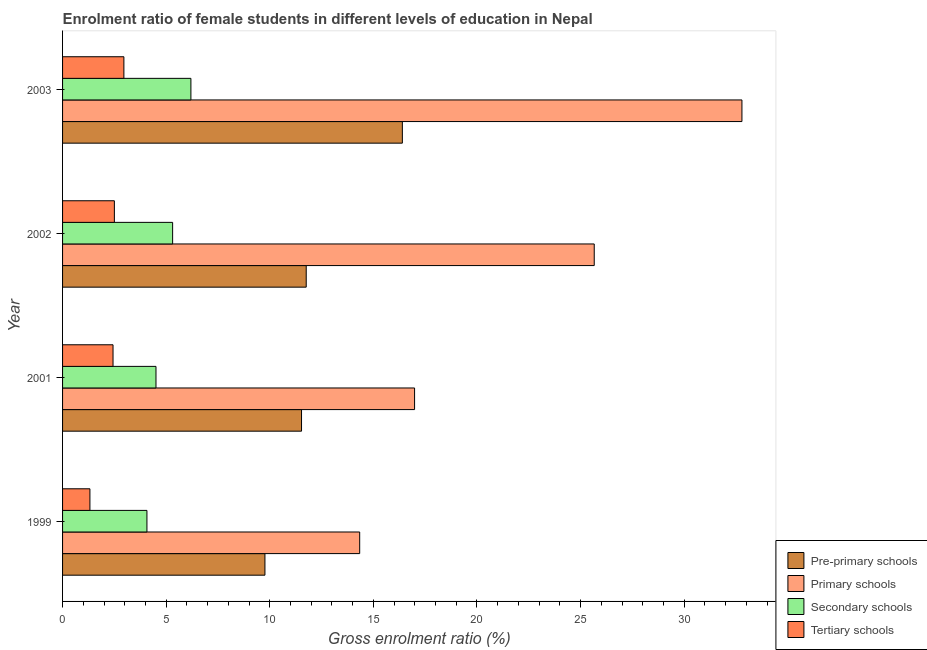How many groups of bars are there?
Provide a succinct answer. 4. Are the number of bars per tick equal to the number of legend labels?
Give a very brief answer. Yes. How many bars are there on the 2nd tick from the bottom?
Give a very brief answer. 4. What is the gross enrolment ratio(male) in primary schools in 2002?
Your response must be concise. 25.66. Across all years, what is the maximum gross enrolment ratio(male) in primary schools?
Offer a terse response. 32.79. Across all years, what is the minimum gross enrolment ratio(male) in primary schools?
Your answer should be very brief. 14.34. In which year was the gross enrolment ratio(male) in primary schools minimum?
Your answer should be compact. 1999. What is the total gross enrolment ratio(male) in primary schools in the graph?
Provide a short and direct response. 89.78. What is the difference between the gross enrolment ratio(male) in secondary schools in 1999 and that in 2001?
Keep it short and to the point. -0.44. What is the difference between the gross enrolment ratio(male) in secondary schools in 2002 and the gross enrolment ratio(male) in primary schools in 2003?
Your response must be concise. -27.48. What is the average gross enrolment ratio(male) in pre-primary schools per year?
Give a very brief answer. 12.37. In the year 2001, what is the difference between the gross enrolment ratio(male) in secondary schools and gross enrolment ratio(male) in primary schools?
Your answer should be compact. -12.48. In how many years, is the gross enrolment ratio(male) in pre-primary schools greater than 23 %?
Give a very brief answer. 0. What is the ratio of the gross enrolment ratio(male) in secondary schools in 1999 to that in 2002?
Keep it short and to the point. 0.77. Is the gross enrolment ratio(male) in tertiary schools in 2001 less than that in 2003?
Ensure brevity in your answer.  Yes. Is the difference between the gross enrolment ratio(male) in secondary schools in 2002 and 2003 greater than the difference between the gross enrolment ratio(male) in pre-primary schools in 2002 and 2003?
Your answer should be compact. Yes. What is the difference between the highest and the second highest gross enrolment ratio(male) in primary schools?
Provide a short and direct response. 7.13. What is the difference between the highest and the lowest gross enrolment ratio(male) in primary schools?
Provide a short and direct response. 18.45. In how many years, is the gross enrolment ratio(male) in primary schools greater than the average gross enrolment ratio(male) in primary schools taken over all years?
Your answer should be compact. 2. Is the sum of the gross enrolment ratio(male) in primary schools in 1999 and 2003 greater than the maximum gross enrolment ratio(male) in pre-primary schools across all years?
Keep it short and to the point. Yes. What does the 4th bar from the top in 2001 represents?
Make the answer very short. Pre-primary schools. What does the 1st bar from the bottom in 2003 represents?
Keep it short and to the point. Pre-primary schools. What is the difference between two consecutive major ticks on the X-axis?
Keep it short and to the point. 5. Does the graph contain any zero values?
Make the answer very short. No. Does the graph contain grids?
Your answer should be compact. No. Where does the legend appear in the graph?
Provide a short and direct response. Bottom right. How many legend labels are there?
Make the answer very short. 4. What is the title of the graph?
Give a very brief answer. Enrolment ratio of female students in different levels of education in Nepal. Does "UNRWA" appear as one of the legend labels in the graph?
Your answer should be very brief. No. What is the label or title of the X-axis?
Your answer should be very brief. Gross enrolment ratio (%). What is the Gross enrolment ratio (%) in Pre-primary schools in 1999?
Provide a succinct answer. 9.77. What is the Gross enrolment ratio (%) in Primary schools in 1999?
Make the answer very short. 14.34. What is the Gross enrolment ratio (%) in Secondary schools in 1999?
Give a very brief answer. 4.07. What is the Gross enrolment ratio (%) in Tertiary schools in 1999?
Provide a short and direct response. 1.32. What is the Gross enrolment ratio (%) in Pre-primary schools in 2001?
Make the answer very short. 11.53. What is the Gross enrolment ratio (%) in Primary schools in 2001?
Ensure brevity in your answer.  16.99. What is the Gross enrolment ratio (%) of Secondary schools in 2001?
Your answer should be compact. 4.51. What is the Gross enrolment ratio (%) of Tertiary schools in 2001?
Make the answer very short. 2.44. What is the Gross enrolment ratio (%) in Pre-primary schools in 2002?
Your answer should be very brief. 11.76. What is the Gross enrolment ratio (%) of Primary schools in 2002?
Provide a short and direct response. 25.66. What is the Gross enrolment ratio (%) of Secondary schools in 2002?
Provide a short and direct response. 5.31. What is the Gross enrolment ratio (%) in Tertiary schools in 2002?
Make the answer very short. 2.5. What is the Gross enrolment ratio (%) in Pre-primary schools in 2003?
Provide a short and direct response. 16.4. What is the Gross enrolment ratio (%) in Primary schools in 2003?
Your response must be concise. 32.79. What is the Gross enrolment ratio (%) in Secondary schools in 2003?
Your answer should be very brief. 6.19. What is the Gross enrolment ratio (%) of Tertiary schools in 2003?
Offer a very short reply. 2.96. Across all years, what is the maximum Gross enrolment ratio (%) in Pre-primary schools?
Your answer should be very brief. 16.4. Across all years, what is the maximum Gross enrolment ratio (%) in Primary schools?
Your response must be concise. 32.79. Across all years, what is the maximum Gross enrolment ratio (%) in Secondary schools?
Ensure brevity in your answer.  6.19. Across all years, what is the maximum Gross enrolment ratio (%) in Tertiary schools?
Ensure brevity in your answer.  2.96. Across all years, what is the minimum Gross enrolment ratio (%) of Pre-primary schools?
Give a very brief answer. 9.77. Across all years, what is the minimum Gross enrolment ratio (%) of Primary schools?
Make the answer very short. 14.34. Across all years, what is the minimum Gross enrolment ratio (%) of Secondary schools?
Provide a short and direct response. 4.07. Across all years, what is the minimum Gross enrolment ratio (%) in Tertiary schools?
Offer a terse response. 1.32. What is the total Gross enrolment ratio (%) of Pre-primary schools in the graph?
Give a very brief answer. 49.46. What is the total Gross enrolment ratio (%) in Primary schools in the graph?
Provide a short and direct response. 89.78. What is the total Gross enrolment ratio (%) in Secondary schools in the graph?
Give a very brief answer. 20.09. What is the total Gross enrolment ratio (%) of Tertiary schools in the graph?
Keep it short and to the point. 9.22. What is the difference between the Gross enrolment ratio (%) of Pre-primary schools in 1999 and that in 2001?
Provide a short and direct response. -1.77. What is the difference between the Gross enrolment ratio (%) in Primary schools in 1999 and that in 2001?
Ensure brevity in your answer.  -2.65. What is the difference between the Gross enrolment ratio (%) in Secondary schools in 1999 and that in 2001?
Offer a very short reply. -0.44. What is the difference between the Gross enrolment ratio (%) in Tertiary schools in 1999 and that in 2001?
Your answer should be very brief. -1.12. What is the difference between the Gross enrolment ratio (%) of Pre-primary schools in 1999 and that in 2002?
Your answer should be very brief. -1.99. What is the difference between the Gross enrolment ratio (%) of Primary schools in 1999 and that in 2002?
Give a very brief answer. -11.32. What is the difference between the Gross enrolment ratio (%) in Secondary schools in 1999 and that in 2002?
Provide a short and direct response. -1.24. What is the difference between the Gross enrolment ratio (%) of Tertiary schools in 1999 and that in 2002?
Ensure brevity in your answer.  -1.18. What is the difference between the Gross enrolment ratio (%) of Pre-primary schools in 1999 and that in 2003?
Provide a short and direct response. -6.63. What is the difference between the Gross enrolment ratio (%) of Primary schools in 1999 and that in 2003?
Make the answer very short. -18.45. What is the difference between the Gross enrolment ratio (%) of Secondary schools in 1999 and that in 2003?
Your answer should be very brief. -2.12. What is the difference between the Gross enrolment ratio (%) of Tertiary schools in 1999 and that in 2003?
Give a very brief answer. -1.64. What is the difference between the Gross enrolment ratio (%) of Pre-primary schools in 2001 and that in 2002?
Provide a succinct answer. -0.23. What is the difference between the Gross enrolment ratio (%) in Primary schools in 2001 and that in 2002?
Keep it short and to the point. -8.67. What is the difference between the Gross enrolment ratio (%) in Secondary schools in 2001 and that in 2002?
Offer a very short reply. -0.8. What is the difference between the Gross enrolment ratio (%) in Tertiary schools in 2001 and that in 2002?
Your response must be concise. -0.06. What is the difference between the Gross enrolment ratio (%) of Pre-primary schools in 2001 and that in 2003?
Your answer should be very brief. -4.87. What is the difference between the Gross enrolment ratio (%) in Primary schools in 2001 and that in 2003?
Offer a terse response. -15.8. What is the difference between the Gross enrolment ratio (%) of Secondary schools in 2001 and that in 2003?
Your response must be concise. -1.69. What is the difference between the Gross enrolment ratio (%) of Tertiary schools in 2001 and that in 2003?
Ensure brevity in your answer.  -0.52. What is the difference between the Gross enrolment ratio (%) of Pre-primary schools in 2002 and that in 2003?
Your response must be concise. -4.64. What is the difference between the Gross enrolment ratio (%) in Primary schools in 2002 and that in 2003?
Ensure brevity in your answer.  -7.13. What is the difference between the Gross enrolment ratio (%) of Secondary schools in 2002 and that in 2003?
Your answer should be compact. -0.88. What is the difference between the Gross enrolment ratio (%) of Tertiary schools in 2002 and that in 2003?
Provide a short and direct response. -0.46. What is the difference between the Gross enrolment ratio (%) in Pre-primary schools in 1999 and the Gross enrolment ratio (%) in Primary schools in 2001?
Offer a terse response. -7.22. What is the difference between the Gross enrolment ratio (%) in Pre-primary schools in 1999 and the Gross enrolment ratio (%) in Secondary schools in 2001?
Your answer should be compact. 5.26. What is the difference between the Gross enrolment ratio (%) of Pre-primary schools in 1999 and the Gross enrolment ratio (%) of Tertiary schools in 2001?
Your response must be concise. 7.33. What is the difference between the Gross enrolment ratio (%) of Primary schools in 1999 and the Gross enrolment ratio (%) of Secondary schools in 2001?
Make the answer very short. 9.83. What is the difference between the Gross enrolment ratio (%) of Primary schools in 1999 and the Gross enrolment ratio (%) of Tertiary schools in 2001?
Provide a succinct answer. 11.9. What is the difference between the Gross enrolment ratio (%) in Secondary schools in 1999 and the Gross enrolment ratio (%) in Tertiary schools in 2001?
Ensure brevity in your answer.  1.64. What is the difference between the Gross enrolment ratio (%) in Pre-primary schools in 1999 and the Gross enrolment ratio (%) in Primary schools in 2002?
Provide a short and direct response. -15.89. What is the difference between the Gross enrolment ratio (%) in Pre-primary schools in 1999 and the Gross enrolment ratio (%) in Secondary schools in 2002?
Your response must be concise. 4.46. What is the difference between the Gross enrolment ratio (%) in Pre-primary schools in 1999 and the Gross enrolment ratio (%) in Tertiary schools in 2002?
Make the answer very short. 7.27. What is the difference between the Gross enrolment ratio (%) of Primary schools in 1999 and the Gross enrolment ratio (%) of Secondary schools in 2002?
Give a very brief answer. 9.03. What is the difference between the Gross enrolment ratio (%) of Primary schools in 1999 and the Gross enrolment ratio (%) of Tertiary schools in 2002?
Offer a very short reply. 11.84. What is the difference between the Gross enrolment ratio (%) in Secondary schools in 1999 and the Gross enrolment ratio (%) in Tertiary schools in 2002?
Offer a very short reply. 1.57. What is the difference between the Gross enrolment ratio (%) in Pre-primary schools in 1999 and the Gross enrolment ratio (%) in Primary schools in 2003?
Provide a short and direct response. -23.02. What is the difference between the Gross enrolment ratio (%) in Pre-primary schools in 1999 and the Gross enrolment ratio (%) in Secondary schools in 2003?
Keep it short and to the point. 3.57. What is the difference between the Gross enrolment ratio (%) in Pre-primary schools in 1999 and the Gross enrolment ratio (%) in Tertiary schools in 2003?
Provide a succinct answer. 6.81. What is the difference between the Gross enrolment ratio (%) of Primary schools in 1999 and the Gross enrolment ratio (%) of Secondary schools in 2003?
Provide a short and direct response. 8.15. What is the difference between the Gross enrolment ratio (%) in Primary schools in 1999 and the Gross enrolment ratio (%) in Tertiary schools in 2003?
Ensure brevity in your answer.  11.38. What is the difference between the Gross enrolment ratio (%) in Secondary schools in 1999 and the Gross enrolment ratio (%) in Tertiary schools in 2003?
Your answer should be compact. 1.11. What is the difference between the Gross enrolment ratio (%) of Pre-primary schools in 2001 and the Gross enrolment ratio (%) of Primary schools in 2002?
Make the answer very short. -14.13. What is the difference between the Gross enrolment ratio (%) in Pre-primary schools in 2001 and the Gross enrolment ratio (%) in Secondary schools in 2002?
Offer a very short reply. 6.22. What is the difference between the Gross enrolment ratio (%) of Pre-primary schools in 2001 and the Gross enrolment ratio (%) of Tertiary schools in 2002?
Offer a terse response. 9.03. What is the difference between the Gross enrolment ratio (%) in Primary schools in 2001 and the Gross enrolment ratio (%) in Secondary schools in 2002?
Your response must be concise. 11.68. What is the difference between the Gross enrolment ratio (%) in Primary schools in 2001 and the Gross enrolment ratio (%) in Tertiary schools in 2002?
Offer a very short reply. 14.49. What is the difference between the Gross enrolment ratio (%) in Secondary schools in 2001 and the Gross enrolment ratio (%) in Tertiary schools in 2002?
Give a very brief answer. 2.01. What is the difference between the Gross enrolment ratio (%) of Pre-primary schools in 2001 and the Gross enrolment ratio (%) of Primary schools in 2003?
Your response must be concise. -21.26. What is the difference between the Gross enrolment ratio (%) in Pre-primary schools in 2001 and the Gross enrolment ratio (%) in Secondary schools in 2003?
Make the answer very short. 5.34. What is the difference between the Gross enrolment ratio (%) in Pre-primary schools in 2001 and the Gross enrolment ratio (%) in Tertiary schools in 2003?
Your answer should be compact. 8.57. What is the difference between the Gross enrolment ratio (%) in Primary schools in 2001 and the Gross enrolment ratio (%) in Secondary schools in 2003?
Offer a very short reply. 10.8. What is the difference between the Gross enrolment ratio (%) in Primary schools in 2001 and the Gross enrolment ratio (%) in Tertiary schools in 2003?
Your answer should be compact. 14.03. What is the difference between the Gross enrolment ratio (%) of Secondary schools in 2001 and the Gross enrolment ratio (%) of Tertiary schools in 2003?
Provide a succinct answer. 1.55. What is the difference between the Gross enrolment ratio (%) in Pre-primary schools in 2002 and the Gross enrolment ratio (%) in Primary schools in 2003?
Give a very brief answer. -21.03. What is the difference between the Gross enrolment ratio (%) in Pre-primary schools in 2002 and the Gross enrolment ratio (%) in Secondary schools in 2003?
Offer a terse response. 5.57. What is the difference between the Gross enrolment ratio (%) in Pre-primary schools in 2002 and the Gross enrolment ratio (%) in Tertiary schools in 2003?
Provide a succinct answer. 8.8. What is the difference between the Gross enrolment ratio (%) in Primary schools in 2002 and the Gross enrolment ratio (%) in Secondary schools in 2003?
Ensure brevity in your answer.  19.47. What is the difference between the Gross enrolment ratio (%) of Primary schools in 2002 and the Gross enrolment ratio (%) of Tertiary schools in 2003?
Your response must be concise. 22.7. What is the difference between the Gross enrolment ratio (%) of Secondary schools in 2002 and the Gross enrolment ratio (%) of Tertiary schools in 2003?
Provide a short and direct response. 2.35. What is the average Gross enrolment ratio (%) of Pre-primary schools per year?
Offer a very short reply. 12.36. What is the average Gross enrolment ratio (%) of Primary schools per year?
Ensure brevity in your answer.  22.44. What is the average Gross enrolment ratio (%) in Secondary schools per year?
Your answer should be very brief. 5.02. What is the average Gross enrolment ratio (%) in Tertiary schools per year?
Your answer should be compact. 2.3. In the year 1999, what is the difference between the Gross enrolment ratio (%) of Pre-primary schools and Gross enrolment ratio (%) of Primary schools?
Offer a terse response. -4.57. In the year 1999, what is the difference between the Gross enrolment ratio (%) in Pre-primary schools and Gross enrolment ratio (%) in Secondary schools?
Offer a terse response. 5.7. In the year 1999, what is the difference between the Gross enrolment ratio (%) in Pre-primary schools and Gross enrolment ratio (%) in Tertiary schools?
Provide a succinct answer. 8.45. In the year 1999, what is the difference between the Gross enrolment ratio (%) in Primary schools and Gross enrolment ratio (%) in Secondary schools?
Your answer should be compact. 10.27. In the year 1999, what is the difference between the Gross enrolment ratio (%) of Primary schools and Gross enrolment ratio (%) of Tertiary schools?
Your response must be concise. 13.02. In the year 1999, what is the difference between the Gross enrolment ratio (%) in Secondary schools and Gross enrolment ratio (%) in Tertiary schools?
Offer a terse response. 2.75. In the year 2001, what is the difference between the Gross enrolment ratio (%) of Pre-primary schools and Gross enrolment ratio (%) of Primary schools?
Your response must be concise. -5.46. In the year 2001, what is the difference between the Gross enrolment ratio (%) in Pre-primary schools and Gross enrolment ratio (%) in Secondary schools?
Your response must be concise. 7.02. In the year 2001, what is the difference between the Gross enrolment ratio (%) of Pre-primary schools and Gross enrolment ratio (%) of Tertiary schools?
Give a very brief answer. 9.1. In the year 2001, what is the difference between the Gross enrolment ratio (%) of Primary schools and Gross enrolment ratio (%) of Secondary schools?
Your response must be concise. 12.48. In the year 2001, what is the difference between the Gross enrolment ratio (%) of Primary schools and Gross enrolment ratio (%) of Tertiary schools?
Provide a short and direct response. 14.55. In the year 2001, what is the difference between the Gross enrolment ratio (%) in Secondary schools and Gross enrolment ratio (%) in Tertiary schools?
Your answer should be very brief. 2.07. In the year 2002, what is the difference between the Gross enrolment ratio (%) in Pre-primary schools and Gross enrolment ratio (%) in Primary schools?
Provide a short and direct response. -13.9. In the year 2002, what is the difference between the Gross enrolment ratio (%) in Pre-primary schools and Gross enrolment ratio (%) in Secondary schools?
Your response must be concise. 6.45. In the year 2002, what is the difference between the Gross enrolment ratio (%) of Pre-primary schools and Gross enrolment ratio (%) of Tertiary schools?
Give a very brief answer. 9.26. In the year 2002, what is the difference between the Gross enrolment ratio (%) of Primary schools and Gross enrolment ratio (%) of Secondary schools?
Keep it short and to the point. 20.35. In the year 2002, what is the difference between the Gross enrolment ratio (%) in Primary schools and Gross enrolment ratio (%) in Tertiary schools?
Offer a very short reply. 23.16. In the year 2002, what is the difference between the Gross enrolment ratio (%) in Secondary schools and Gross enrolment ratio (%) in Tertiary schools?
Your answer should be very brief. 2.81. In the year 2003, what is the difference between the Gross enrolment ratio (%) of Pre-primary schools and Gross enrolment ratio (%) of Primary schools?
Your answer should be very brief. -16.39. In the year 2003, what is the difference between the Gross enrolment ratio (%) in Pre-primary schools and Gross enrolment ratio (%) in Secondary schools?
Ensure brevity in your answer.  10.21. In the year 2003, what is the difference between the Gross enrolment ratio (%) in Pre-primary schools and Gross enrolment ratio (%) in Tertiary schools?
Give a very brief answer. 13.44. In the year 2003, what is the difference between the Gross enrolment ratio (%) in Primary schools and Gross enrolment ratio (%) in Secondary schools?
Offer a terse response. 26.59. In the year 2003, what is the difference between the Gross enrolment ratio (%) of Primary schools and Gross enrolment ratio (%) of Tertiary schools?
Ensure brevity in your answer.  29.83. In the year 2003, what is the difference between the Gross enrolment ratio (%) in Secondary schools and Gross enrolment ratio (%) in Tertiary schools?
Make the answer very short. 3.23. What is the ratio of the Gross enrolment ratio (%) in Pre-primary schools in 1999 to that in 2001?
Make the answer very short. 0.85. What is the ratio of the Gross enrolment ratio (%) of Primary schools in 1999 to that in 2001?
Offer a terse response. 0.84. What is the ratio of the Gross enrolment ratio (%) in Secondary schools in 1999 to that in 2001?
Provide a succinct answer. 0.9. What is the ratio of the Gross enrolment ratio (%) in Tertiary schools in 1999 to that in 2001?
Provide a succinct answer. 0.54. What is the ratio of the Gross enrolment ratio (%) in Pre-primary schools in 1999 to that in 2002?
Your answer should be very brief. 0.83. What is the ratio of the Gross enrolment ratio (%) in Primary schools in 1999 to that in 2002?
Ensure brevity in your answer.  0.56. What is the ratio of the Gross enrolment ratio (%) in Secondary schools in 1999 to that in 2002?
Give a very brief answer. 0.77. What is the ratio of the Gross enrolment ratio (%) of Tertiary schools in 1999 to that in 2002?
Your response must be concise. 0.53. What is the ratio of the Gross enrolment ratio (%) of Pre-primary schools in 1999 to that in 2003?
Provide a short and direct response. 0.6. What is the ratio of the Gross enrolment ratio (%) of Primary schools in 1999 to that in 2003?
Ensure brevity in your answer.  0.44. What is the ratio of the Gross enrolment ratio (%) in Secondary schools in 1999 to that in 2003?
Give a very brief answer. 0.66. What is the ratio of the Gross enrolment ratio (%) in Tertiary schools in 1999 to that in 2003?
Ensure brevity in your answer.  0.45. What is the ratio of the Gross enrolment ratio (%) of Pre-primary schools in 2001 to that in 2002?
Your answer should be very brief. 0.98. What is the ratio of the Gross enrolment ratio (%) of Primary schools in 2001 to that in 2002?
Keep it short and to the point. 0.66. What is the ratio of the Gross enrolment ratio (%) in Secondary schools in 2001 to that in 2002?
Keep it short and to the point. 0.85. What is the ratio of the Gross enrolment ratio (%) of Pre-primary schools in 2001 to that in 2003?
Make the answer very short. 0.7. What is the ratio of the Gross enrolment ratio (%) of Primary schools in 2001 to that in 2003?
Give a very brief answer. 0.52. What is the ratio of the Gross enrolment ratio (%) in Secondary schools in 2001 to that in 2003?
Provide a succinct answer. 0.73. What is the ratio of the Gross enrolment ratio (%) in Tertiary schools in 2001 to that in 2003?
Provide a succinct answer. 0.82. What is the ratio of the Gross enrolment ratio (%) in Pre-primary schools in 2002 to that in 2003?
Your response must be concise. 0.72. What is the ratio of the Gross enrolment ratio (%) in Primary schools in 2002 to that in 2003?
Provide a succinct answer. 0.78. What is the ratio of the Gross enrolment ratio (%) in Secondary schools in 2002 to that in 2003?
Make the answer very short. 0.86. What is the ratio of the Gross enrolment ratio (%) of Tertiary schools in 2002 to that in 2003?
Your response must be concise. 0.84. What is the difference between the highest and the second highest Gross enrolment ratio (%) of Pre-primary schools?
Give a very brief answer. 4.64. What is the difference between the highest and the second highest Gross enrolment ratio (%) of Primary schools?
Your response must be concise. 7.13. What is the difference between the highest and the second highest Gross enrolment ratio (%) of Secondary schools?
Offer a terse response. 0.88. What is the difference between the highest and the second highest Gross enrolment ratio (%) in Tertiary schools?
Ensure brevity in your answer.  0.46. What is the difference between the highest and the lowest Gross enrolment ratio (%) of Pre-primary schools?
Provide a succinct answer. 6.63. What is the difference between the highest and the lowest Gross enrolment ratio (%) of Primary schools?
Your answer should be very brief. 18.45. What is the difference between the highest and the lowest Gross enrolment ratio (%) of Secondary schools?
Your response must be concise. 2.12. What is the difference between the highest and the lowest Gross enrolment ratio (%) of Tertiary schools?
Provide a short and direct response. 1.64. 